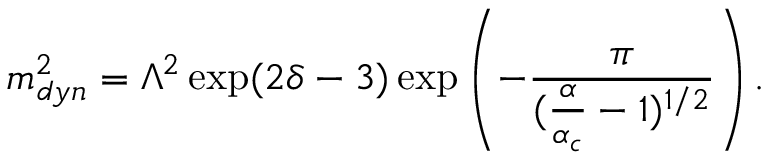<formula> <loc_0><loc_0><loc_500><loc_500>m _ { d y n } ^ { 2 } = \Lambda ^ { 2 } \exp ( 2 \delta - 3 ) \exp \left ( - \frac { \pi } { ( \frac { \alpha } { \alpha _ { c } } - 1 ) ^ { 1 / 2 } } \right ) .</formula> 